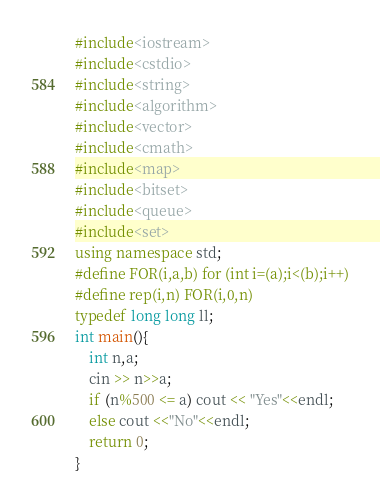<code> <loc_0><loc_0><loc_500><loc_500><_C++_>#include<iostream>
#include<cstdio>
#include<string>
#include<algorithm>
#include<vector>
#include<cmath>
#include<map>
#include<bitset>
#include<queue>
#include<set>
using namespace std;
#define FOR(i,a,b) for (int i=(a);i<(b);i++)
#define rep(i,n) FOR(i,0,n)
typedef long long ll;
int main(){
	int n,a;
	cin >> n>>a;
	if (n%500 <= a) cout << "Yes"<<endl;
	else cout <<"No"<<endl;
	return 0;
}
</code> 